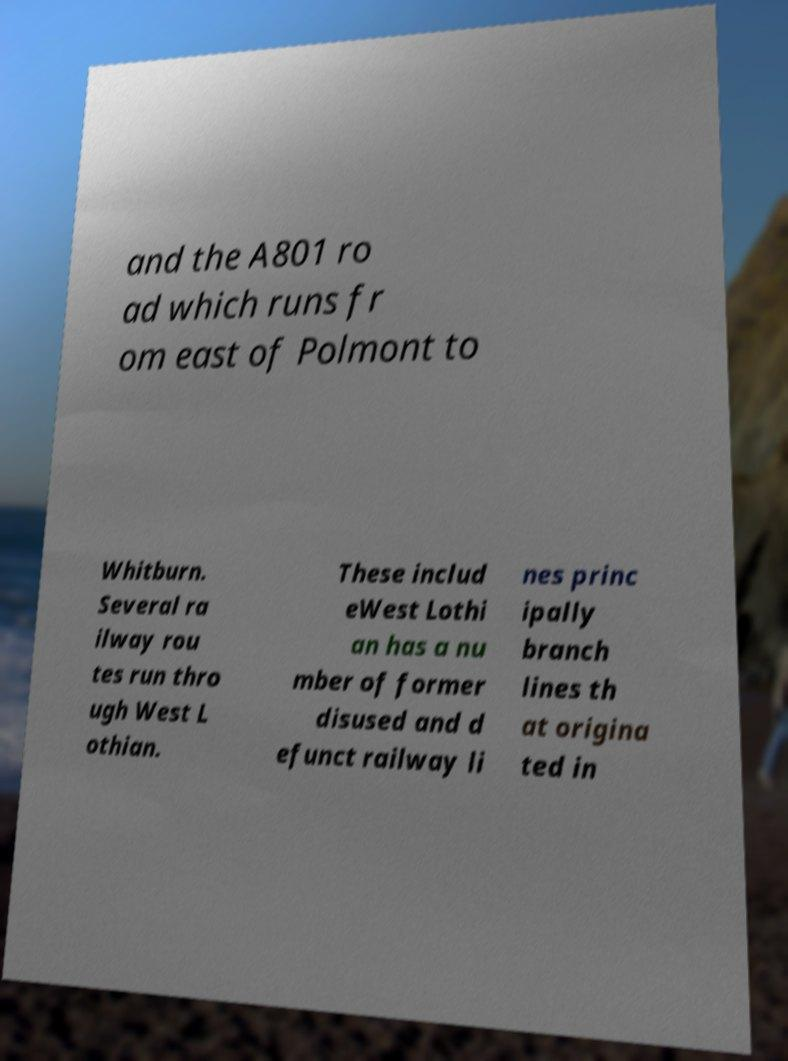What messages or text are displayed in this image? I need them in a readable, typed format. and the A801 ro ad which runs fr om east of Polmont to Whitburn. Several ra ilway rou tes run thro ugh West L othian. These includ eWest Lothi an has a nu mber of former disused and d efunct railway li nes princ ipally branch lines th at origina ted in 